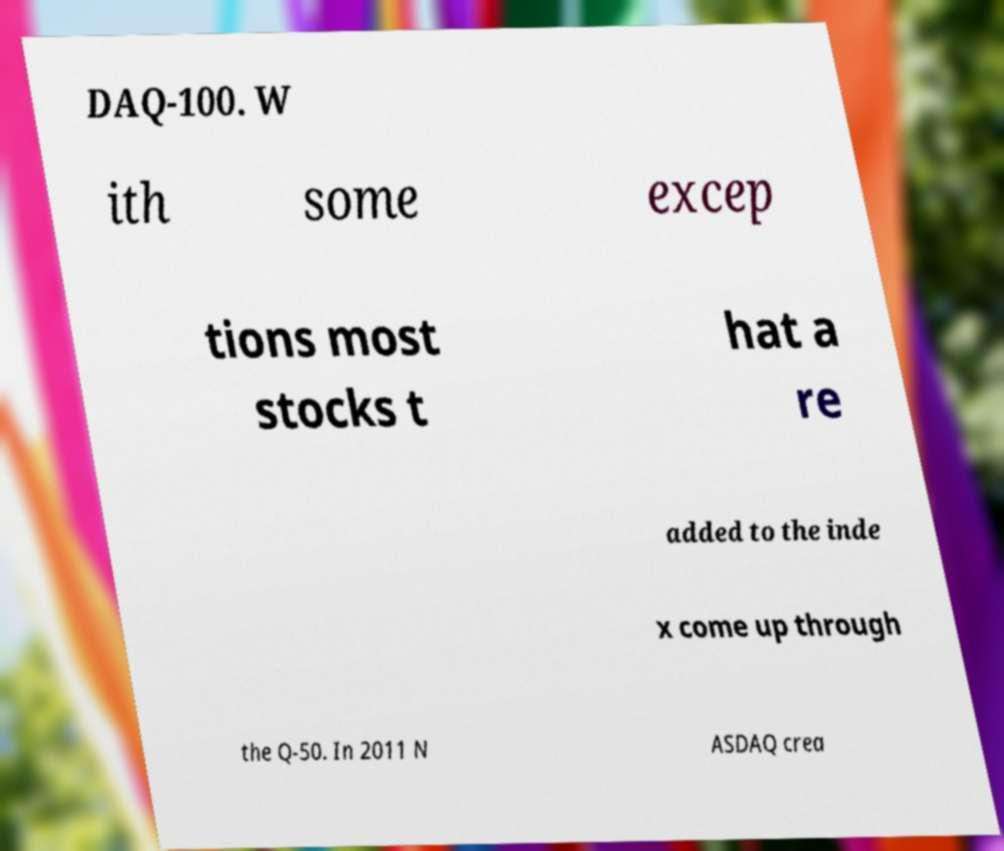I need the written content from this picture converted into text. Can you do that? DAQ-100. W ith some excep tions most stocks t hat a re added to the inde x come up through the Q-50. In 2011 N ASDAQ crea 